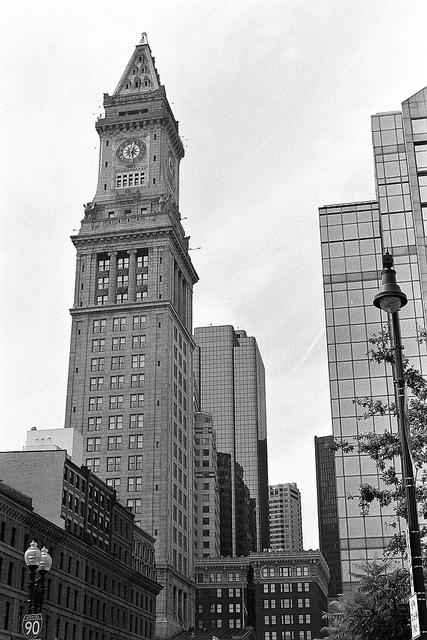Are there people visible?
Short answer required. No. Is the picture in black and white?
Write a very short answer. Yes. Where is the famous landmark in the picture?
Quick response, please. Big ben. What color is the sky?
Be succinct. Gray. Is the clock tower the tallest building?
Quick response, please. Yes. 